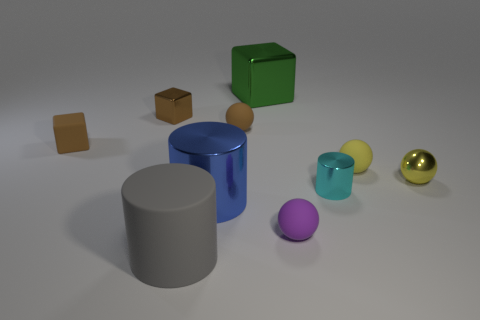Subtract all big gray cylinders. How many cylinders are left? 2 Subtract 1 cylinders. How many cylinders are left? 2 Subtract all big green shiny blocks. Subtract all big cubes. How many objects are left? 8 Add 4 large blue shiny things. How many large blue shiny things are left? 5 Add 2 big yellow balls. How many big yellow balls exist? 2 Subtract all purple balls. How many balls are left? 3 Subtract 0 purple blocks. How many objects are left? 10 Subtract all balls. How many objects are left? 6 Subtract all purple blocks. Subtract all red balls. How many blocks are left? 3 Subtract all green spheres. How many blue cylinders are left? 1 